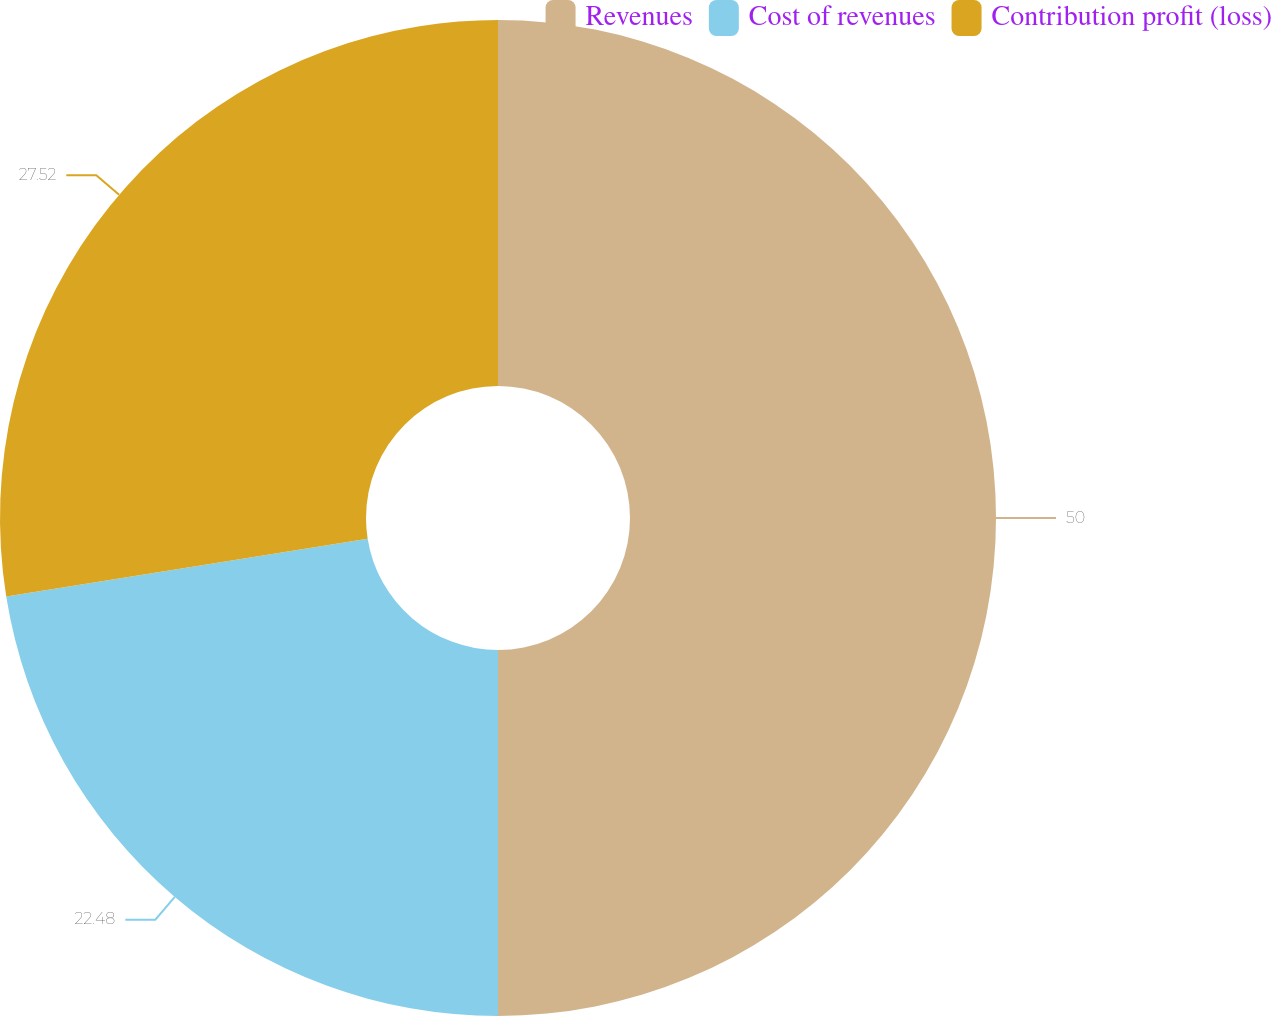Convert chart to OTSL. <chart><loc_0><loc_0><loc_500><loc_500><pie_chart><fcel>Revenues<fcel>Cost of revenues<fcel>Contribution profit (loss)<nl><fcel>50.0%<fcel>22.48%<fcel>27.52%<nl></chart> 